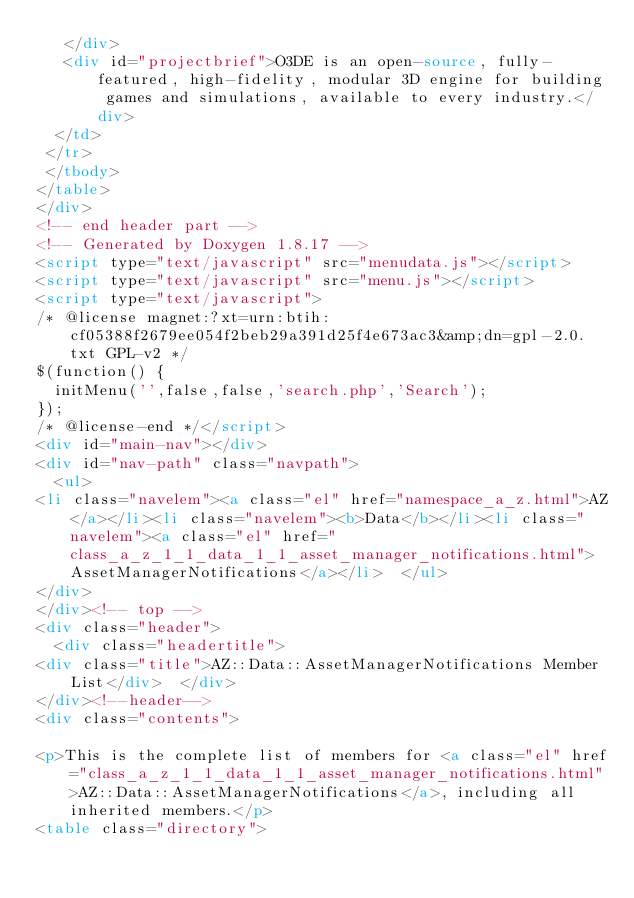Convert code to text. <code><loc_0><loc_0><loc_500><loc_500><_HTML_>   </div>
   <div id="projectbrief">O3DE is an open-source, fully-featured, high-fidelity, modular 3D engine for building games and simulations, available to every industry.</div>
  </td>
 </tr>
 </tbody>
</table>
</div>
<!-- end header part -->
<!-- Generated by Doxygen 1.8.17 -->
<script type="text/javascript" src="menudata.js"></script>
<script type="text/javascript" src="menu.js"></script>
<script type="text/javascript">
/* @license magnet:?xt=urn:btih:cf05388f2679ee054f2beb29a391d25f4e673ac3&amp;dn=gpl-2.0.txt GPL-v2 */
$(function() {
  initMenu('',false,false,'search.php','Search');
});
/* @license-end */</script>
<div id="main-nav"></div>
<div id="nav-path" class="navpath">
  <ul>
<li class="navelem"><a class="el" href="namespace_a_z.html">AZ</a></li><li class="navelem"><b>Data</b></li><li class="navelem"><a class="el" href="class_a_z_1_1_data_1_1_asset_manager_notifications.html">AssetManagerNotifications</a></li>  </ul>
</div>
</div><!-- top -->
<div class="header">
  <div class="headertitle">
<div class="title">AZ::Data::AssetManagerNotifications Member List</div>  </div>
</div><!--header-->
<div class="contents">

<p>This is the complete list of members for <a class="el" href="class_a_z_1_1_data_1_1_asset_manager_notifications.html">AZ::Data::AssetManagerNotifications</a>, including all inherited members.</p>
<table class="directory"></code> 